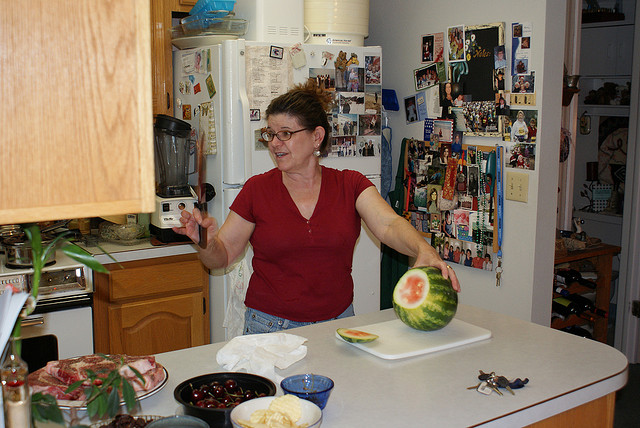How many bowls are visible? 2 